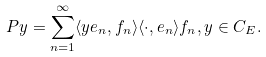Convert formula to latex. <formula><loc_0><loc_0><loc_500><loc_500>P y = \sum _ { n = 1 } ^ { \infty } \langle y e _ { n } , f _ { n } \rangle \langle \cdot , e _ { n } \rangle f _ { n } , y \in C _ { E } .</formula> 